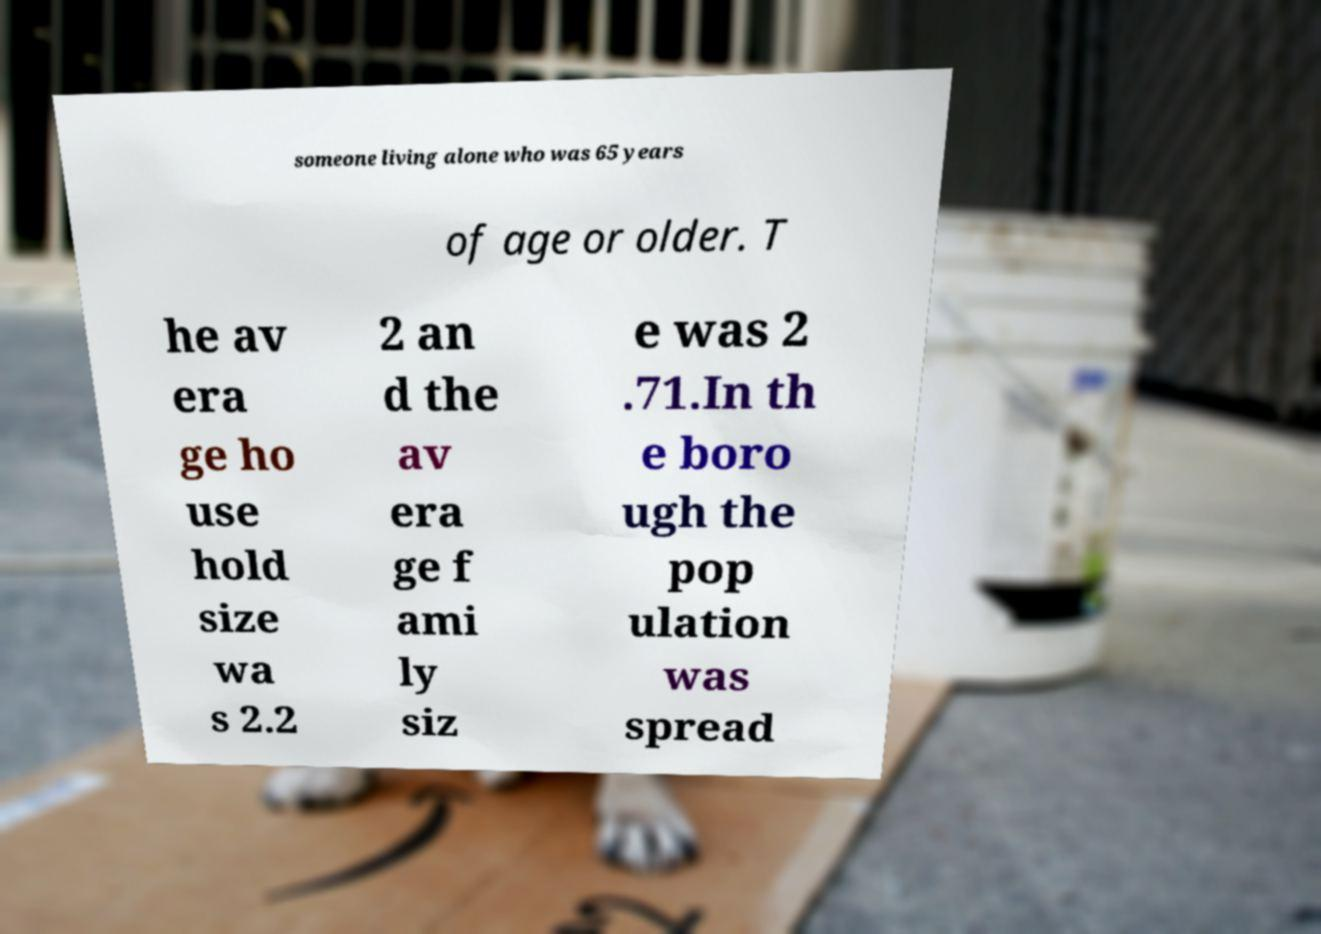What messages or text are displayed in this image? I need them in a readable, typed format. someone living alone who was 65 years of age or older. T he av era ge ho use hold size wa s 2.2 2 an d the av era ge f ami ly siz e was 2 .71.In th e boro ugh the pop ulation was spread 